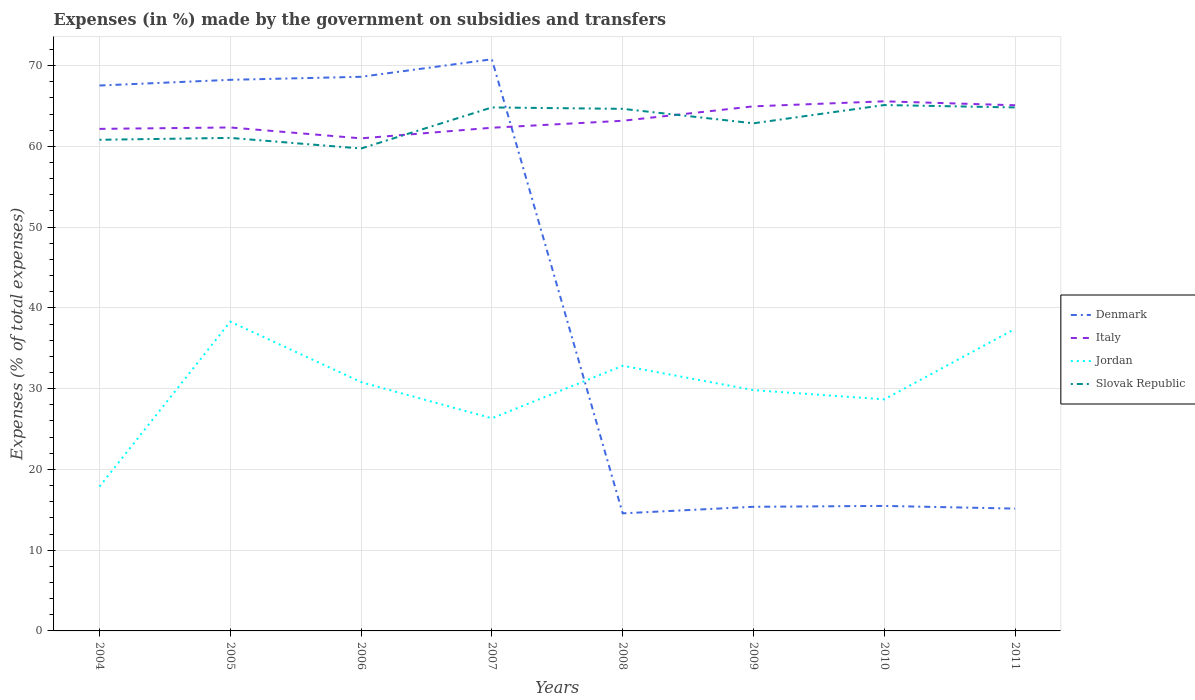Across all years, what is the maximum percentage of expenses made by the government on subsidies and transfers in Slovak Republic?
Your response must be concise. 59.74. What is the total percentage of expenses made by the government on subsidies and transfers in Slovak Republic in the graph?
Your answer should be compact. -3.12. What is the difference between the highest and the second highest percentage of expenses made by the government on subsidies and transfers in Denmark?
Make the answer very short. 56.23. How many lines are there?
Your response must be concise. 4. How many years are there in the graph?
Provide a short and direct response. 8. What is the difference between two consecutive major ticks on the Y-axis?
Your response must be concise. 10. Are the values on the major ticks of Y-axis written in scientific E-notation?
Offer a terse response. No. Does the graph contain any zero values?
Offer a very short reply. No. Does the graph contain grids?
Keep it short and to the point. Yes. How many legend labels are there?
Give a very brief answer. 4. How are the legend labels stacked?
Keep it short and to the point. Vertical. What is the title of the graph?
Ensure brevity in your answer.  Expenses (in %) made by the government on subsidies and transfers. Does "Gambia, The" appear as one of the legend labels in the graph?
Provide a short and direct response. No. What is the label or title of the X-axis?
Provide a succinct answer. Years. What is the label or title of the Y-axis?
Provide a succinct answer. Expenses (% of total expenses). What is the Expenses (% of total expenses) in Denmark in 2004?
Ensure brevity in your answer.  67.54. What is the Expenses (% of total expenses) in Italy in 2004?
Give a very brief answer. 62.17. What is the Expenses (% of total expenses) in Jordan in 2004?
Provide a short and direct response. 17.87. What is the Expenses (% of total expenses) in Slovak Republic in 2004?
Your answer should be very brief. 60.82. What is the Expenses (% of total expenses) in Denmark in 2005?
Offer a very short reply. 68.24. What is the Expenses (% of total expenses) in Italy in 2005?
Provide a short and direct response. 62.34. What is the Expenses (% of total expenses) of Jordan in 2005?
Your answer should be compact. 38.3. What is the Expenses (% of total expenses) of Slovak Republic in 2005?
Your response must be concise. 61.05. What is the Expenses (% of total expenses) in Denmark in 2006?
Offer a very short reply. 68.62. What is the Expenses (% of total expenses) of Italy in 2006?
Your response must be concise. 60.99. What is the Expenses (% of total expenses) in Jordan in 2006?
Your answer should be compact. 30.81. What is the Expenses (% of total expenses) in Slovak Republic in 2006?
Offer a terse response. 59.74. What is the Expenses (% of total expenses) in Denmark in 2007?
Your answer should be very brief. 70.79. What is the Expenses (% of total expenses) in Italy in 2007?
Your answer should be very brief. 62.31. What is the Expenses (% of total expenses) of Jordan in 2007?
Offer a very short reply. 26.33. What is the Expenses (% of total expenses) in Slovak Republic in 2007?
Ensure brevity in your answer.  64.82. What is the Expenses (% of total expenses) of Denmark in 2008?
Ensure brevity in your answer.  14.56. What is the Expenses (% of total expenses) in Italy in 2008?
Provide a succinct answer. 63.17. What is the Expenses (% of total expenses) of Jordan in 2008?
Your answer should be compact. 32.84. What is the Expenses (% of total expenses) of Slovak Republic in 2008?
Offer a very short reply. 64.65. What is the Expenses (% of total expenses) in Denmark in 2009?
Offer a terse response. 15.37. What is the Expenses (% of total expenses) of Italy in 2009?
Make the answer very short. 64.96. What is the Expenses (% of total expenses) of Jordan in 2009?
Provide a short and direct response. 29.82. What is the Expenses (% of total expenses) of Slovak Republic in 2009?
Keep it short and to the point. 62.86. What is the Expenses (% of total expenses) in Denmark in 2010?
Your answer should be very brief. 15.48. What is the Expenses (% of total expenses) in Italy in 2010?
Make the answer very short. 65.58. What is the Expenses (% of total expenses) of Jordan in 2010?
Provide a short and direct response. 28.67. What is the Expenses (% of total expenses) of Slovak Republic in 2010?
Your answer should be very brief. 65.12. What is the Expenses (% of total expenses) of Denmark in 2011?
Provide a short and direct response. 15.15. What is the Expenses (% of total expenses) of Italy in 2011?
Provide a succinct answer. 65.09. What is the Expenses (% of total expenses) in Jordan in 2011?
Give a very brief answer. 37.4. What is the Expenses (% of total expenses) in Slovak Republic in 2011?
Provide a succinct answer. 64.82. Across all years, what is the maximum Expenses (% of total expenses) of Denmark?
Your response must be concise. 70.79. Across all years, what is the maximum Expenses (% of total expenses) in Italy?
Ensure brevity in your answer.  65.58. Across all years, what is the maximum Expenses (% of total expenses) of Jordan?
Ensure brevity in your answer.  38.3. Across all years, what is the maximum Expenses (% of total expenses) in Slovak Republic?
Your answer should be very brief. 65.12. Across all years, what is the minimum Expenses (% of total expenses) in Denmark?
Give a very brief answer. 14.56. Across all years, what is the minimum Expenses (% of total expenses) of Italy?
Your answer should be compact. 60.99. Across all years, what is the minimum Expenses (% of total expenses) of Jordan?
Your answer should be very brief. 17.87. Across all years, what is the minimum Expenses (% of total expenses) of Slovak Republic?
Your answer should be compact. 59.74. What is the total Expenses (% of total expenses) in Denmark in the graph?
Your answer should be compact. 335.73. What is the total Expenses (% of total expenses) of Italy in the graph?
Provide a succinct answer. 506.61. What is the total Expenses (% of total expenses) in Jordan in the graph?
Your answer should be compact. 242.04. What is the total Expenses (% of total expenses) of Slovak Republic in the graph?
Give a very brief answer. 503.87. What is the difference between the Expenses (% of total expenses) in Denmark in 2004 and that in 2005?
Offer a very short reply. -0.7. What is the difference between the Expenses (% of total expenses) of Italy in 2004 and that in 2005?
Provide a succinct answer. -0.17. What is the difference between the Expenses (% of total expenses) of Jordan in 2004 and that in 2005?
Provide a succinct answer. -20.43. What is the difference between the Expenses (% of total expenses) in Slovak Republic in 2004 and that in 2005?
Your answer should be very brief. -0.23. What is the difference between the Expenses (% of total expenses) of Denmark in 2004 and that in 2006?
Your answer should be compact. -1.08. What is the difference between the Expenses (% of total expenses) in Italy in 2004 and that in 2006?
Provide a short and direct response. 1.17. What is the difference between the Expenses (% of total expenses) in Jordan in 2004 and that in 2006?
Your answer should be compact. -12.94. What is the difference between the Expenses (% of total expenses) in Slovak Republic in 2004 and that in 2006?
Keep it short and to the point. 1.08. What is the difference between the Expenses (% of total expenses) in Denmark in 2004 and that in 2007?
Ensure brevity in your answer.  -3.25. What is the difference between the Expenses (% of total expenses) in Italy in 2004 and that in 2007?
Provide a short and direct response. -0.14. What is the difference between the Expenses (% of total expenses) in Jordan in 2004 and that in 2007?
Your answer should be compact. -8.46. What is the difference between the Expenses (% of total expenses) in Slovak Republic in 2004 and that in 2007?
Give a very brief answer. -4. What is the difference between the Expenses (% of total expenses) in Denmark in 2004 and that in 2008?
Give a very brief answer. 52.98. What is the difference between the Expenses (% of total expenses) of Italy in 2004 and that in 2008?
Your response must be concise. -1. What is the difference between the Expenses (% of total expenses) in Jordan in 2004 and that in 2008?
Your answer should be very brief. -14.96. What is the difference between the Expenses (% of total expenses) in Slovak Republic in 2004 and that in 2008?
Keep it short and to the point. -3.83. What is the difference between the Expenses (% of total expenses) of Denmark in 2004 and that in 2009?
Provide a succinct answer. 52.17. What is the difference between the Expenses (% of total expenses) of Italy in 2004 and that in 2009?
Offer a very short reply. -2.79. What is the difference between the Expenses (% of total expenses) of Jordan in 2004 and that in 2009?
Ensure brevity in your answer.  -11.95. What is the difference between the Expenses (% of total expenses) of Slovak Republic in 2004 and that in 2009?
Your answer should be very brief. -2.04. What is the difference between the Expenses (% of total expenses) in Denmark in 2004 and that in 2010?
Give a very brief answer. 52.06. What is the difference between the Expenses (% of total expenses) in Italy in 2004 and that in 2010?
Give a very brief answer. -3.41. What is the difference between the Expenses (% of total expenses) of Jordan in 2004 and that in 2010?
Make the answer very short. -10.8. What is the difference between the Expenses (% of total expenses) of Slovak Republic in 2004 and that in 2010?
Your answer should be very brief. -4.3. What is the difference between the Expenses (% of total expenses) in Denmark in 2004 and that in 2011?
Offer a very short reply. 52.39. What is the difference between the Expenses (% of total expenses) in Italy in 2004 and that in 2011?
Offer a terse response. -2.92. What is the difference between the Expenses (% of total expenses) in Jordan in 2004 and that in 2011?
Ensure brevity in your answer.  -19.53. What is the difference between the Expenses (% of total expenses) in Slovak Republic in 2004 and that in 2011?
Keep it short and to the point. -4. What is the difference between the Expenses (% of total expenses) in Denmark in 2005 and that in 2006?
Give a very brief answer. -0.37. What is the difference between the Expenses (% of total expenses) of Italy in 2005 and that in 2006?
Your answer should be compact. 1.35. What is the difference between the Expenses (% of total expenses) in Jordan in 2005 and that in 2006?
Give a very brief answer. 7.49. What is the difference between the Expenses (% of total expenses) of Slovak Republic in 2005 and that in 2006?
Ensure brevity in your answer.  1.31. What is the difference between the Expenses (% of total expenses) of Denmark in 2005 and that in 2007?
Keep it short and to the point. -2.54. What is the difference between the Expenses (% of total expenses) in Jordan in 2005 and that in 2007?
Your answer should be very brief. 11.97. What is the difference between the Expenses (% of total expenses) in Slovak Republic in 2005 and that in 2007?
Keep it short and to the point. -3.77. What is the difference between the Expenses (% of total expenses) in Denmark in 2005 and that in 2008?
Ensure brevity in your answer.  53.68. What is the difference between the Expenses (% of total expenses) of Italy in 2005 and that in 2008?
Your answer should be compact. -0.83. What is the difference between the Expenses (% of total expenses) of Jordan in 2005 and that in 2008?
Your answer should be compact. 5.47. What is the difference between the Expenses (% of total expenses) in Slovak Republic in 2005 and that in 2008?
Offer a terse response. -3.6. What is the difference between the Expenses (% of total expenses) in Denmark in 2005 and that in 2009?
Keep it short and to the point. 52.87. What is the difference between the Expenses (% of total expenses) in Italy in 2005 and that in 2009?
Give a very brief answer. -2.62. What is the difference between the Expenses (% of total expenses) in Jordan in 2005 and that in 2009?
Make the answer very short. 8.48. What is the difference between the Expenses (% of total expenses) in Slovak Republic in 2005 and that in 2009?
Offer a terse response. -1.81. What is the difference between the Expenses (% of total expenses) of Denmark in 2005 and that in 2010?
Your response must be concise. 52.76. What is the difference between the Expenses (% of total expenses) of Italy in 2005 and that in 2010?
Offer a terse response. -3.24. What is the difference between the Expenses (% of total expenses) of Jordan in 2005 and that in 2010?
Keep it short and to the point. 9.63. What is the difference between the Expenses (% of total expenses) of Slovak Republic in 2005 and that in 2010?
Keep it short and to the point. -4.07. What is the difference between the Expenses (% of total expenses) in Denmark in 2005 and that in 2011?
Your answer should be compact. 53.09. What is the difference between the Expenses (% of total expenses) in Italy in 2005 and that in 2011?
Provide a short and direct response. -2.75. What is the difference between the Expenses (% of total expenses) of Jordan in 2005 and that in 2011?
Ensure brevity in your answer.  0.9. What is the difference between the Expenses (% of total expenses) of Slovak Republic in 2005 and that in 2011?
Make the answer very short. -3.77. What is the difference between the Expenses (% of total expenses) in Denmark in 2006 and that in 2007?
Keep it short and to the point. -2.17. What is the difference between the Expenses (% of total expenses) of Italy in 2006 and that in 2007?
Keep it short and to the point. -1.32. What is the difference between the Expenses (% of total expenses) of Jordan in 2006 and that in 2007?
Offer a terse response. 4.48. What is the difference between the Expenses (% of total expenses) of Slovak Republic in 2006 and that in 2007?
Provide a succinct answer. -5.09. What is the difference between the Expenses (% of total expenses) of Denmark in 2006 and that in 2008?
Keep it short and to the point. 54.06. What is the difference between the Expenses (% of total expenses) in Italy in 2006 and that in 2008?
Your answer should be compact. -2.18. What is the difference between the Expenses (% of total expenses) of Jordan in 2006 and that in 2008?
Keep it short and to the point. -2.03. What is the difference between the Expenses (% of total expenses) in Slovak Republic in 2006 and that in 2008?
Ensure brevity in your answer.  -4.91. What is the difference between the Expenses (% of total expenses) of Denmark in 2006 and that in 2009?
Your response must be concise. 53.24. What is the difference between the Expenses (% of total expenses) in Italy in 2006 and that in 2009?
Ensure brevity in your answer.  -3.96. What is the difference between the Expenses (% of total expenses) in Slovak Republic in 2006 and that in 2009?
Your response must be concise. -3.12. What is the difference between the Expenses (% of total expenses) of Denmark in 2006 and that in 2010?
Keep it short and to the point. 53.14. What is the difference between the Expenses (% of total expenses) in Italy in 2006 and that in 2010?
Your response must be concise. -4.59. What is the difference between the Expenses (% of total expenses) of Jordan in 2006 and that in 2010?
Offer a very short reply. 2.14. What is the difference between the Expenses (% of total expenses) in Slovak Republic in 2006 and that in 2010?
Offer a terse response. -5.38. What is the difference between the Expenses (% of total expenses) in Denmark in 2006 and that in 2011?
Offer a terse response. 53.47. What is the difference between the Expenses (% of total expenses) in Italy in 2006 and that in 2011?
Keep it short and to the point. -4.1. What is the difference between the Expenses (% of total expenses) of Jordan in 2006 and that in 2011?
Keep it short and to the point. -6.59. What is the difference between the Expenses (% of total expenses) of Slovak Republic in 2006 and that in 2011?
Offer a terse response. -5.08. What is the difference between the Expenses (% of total expenses) of Denmark in 2007 and that in 2008?
Provide a succinct answer. 56.23. What is the difference between the Expenses (% of total expenses) in Italy in 2007 and that in 2008?
Provide a short and direct response. -0.86. What is the difference between the Expenses (% of total expenses) of Jordan in 2007 and that in 2008?
Your answer should be very brief. -6.51. What is the difference between the Expenses (% of total expenses) of Slovak Republic in 2007 and that in 2008?
Ensure brevity in your answer.  0.17. What is the difference between the Expenses (% of total expenses) of Denmark in 2007 and that in 2009?
Your response must be concise. 55.41. What is the difference between the Expenses (% of total expenses) in Italy in 2007 and that in 2009?
Your answer should be compact. -2.65. What is the difference between the Expenses (% of total expenses) in Jordan in 2007 and that in 2009?
Make the answer very short. -3.49. What is the difference between the Expenses (% of total expenses) of Slovak Republic in 2007 and that in 2009?
Ensure brevity in your answer.  1.96. What is the difference between the Expenses (% of total expenses) of Denmark in 2007 and that in 2010?
Your response must be concise. 55.31. What is the difference between the Expenses (% of total expenses) in Italy in 2007 and that in 2010?
Your answer should be compact. -3.27. What is the difference between the Expenses (% of total expenses) of Jordan in 2007 and that in 2010?
Give a very brief answer. -2.34. What is the difference between the Expenses (% of total expenses) of Slovak Republic in 2007 and that in 2010?
Provide a short and direct response. -0.3. What is the difference between the Expenses (% of total expenses) of Denmark in 2007 and that in 2011?
Make the answer very short. 55.64. What is the difference between the Expenses (% of total expenses) of Italy in 2007 and that in 2011?
Offer a very short reply. -2.78. What is the difference between the Expenses (% of total expenses) in Jordan in 2007 and that in 2011?
Your response must be concise. -11.07. What is the difference between the Expenses (% of total expenses) in Slovak Republic in 2007 and that in 2011?
Provide a short and direct response. 0. What is the difference between the Expenses (% of total expenses) of Denmark in 2008 and that in 2009?
Your response must be concise. -0.81. What is the difference between the Expenses (% of total expenses) in Italy in 2008 and that in 2009?
Keep it short and to the point. -1.79. What is the difference between the Expenses (% of total expenses) in Jordan in 2008 and that in 2009?
Your response must be concise. 3.02. What is the difference between the Expenses (% of total expenses) of Slovak Republic in 2008 and that in 2009?
Your answer should be very brief. 1.79. What is the difference between the Expenses (% of total expenses) in Denmark in 2008 and that in 2010?
Provide a short and direct response. -0.92. What is the difference between the Expenses (% of total expenses) in Italy in 2008 and that in 2010?
Your response must be concise. -2.41. What is the difference between the Expenses (% of total expenses) of Jordan in 2008 and that in 2010?
Provide a short and direct response. 4.16. What is the difference between the Expenses (% of total expenses) in Slovak Republic in 2008 and that in 2010?
Keep it short and to the point. -0.47. What is the difference between the Expenses (% of total expenses) in Denmark in 2008 and that in 2011?
Provide a succinct answer. -0.59. What is the difference between the Expenses (% of total expenses) in Italy in 2008 and that in 2011?
Make the answer very short. -1.92. What is the difference between the Expenses (% of total expenses) in Jordan in 2008 and that in 2011?
Your answer should be compact. -4.57. What is the difference between the Expenses (% of total expenses) in Slovak Republic in 2008 and that in 2011?
Provide a short and direct response. -0.17. What is the difference between the Expenses (% of total expenses) of Denmark in 2009 and that in 2010?
Offer a terse response. -0.11. What is the difference between the Expenses (% of total expenses) of Italy in 2009 and that in 2010?
Make the answer very short. -0.62. What is the difference between the Expenses (% of total expenses) in Jordan in 2009 and that in 2010?
Give a very brief answer. 1.14. What is the difference between the Expenses (% of total expenses) of Slovak Republic in 2009 and that in 2010?
Ensure brevity in your answer.  -2.26. What is the difference between the Expenses (% of total expenses) of Denmark in 2009 and that in 2011?
Offer a very short reply. 0.22. What is the difference between the Expenses (% of total expenses) in Italy in 2009 and that in 2011?
Provide a succinct answer. -0.13. What is the difference between the Expenses (% of total expenses) of Jordan in 2009 and that in 2011?
Make the answer very short. -7.58. What is the difference between the Expenses (% of total expenses) in Slovak Republic in 2009 and that in 2011?
Offer a terse response. -1.96. What is the difference between the Expenses (% of total expenses) of Denmark in 2010 and that in 2011?
Make the answer very short. 0.33. What is the difference between the Expenses (% of total expenses) of Italy in 2010 and that in 2011?
Provide a succinct answer. 0.49. What is the difference between the Expenses (% of total expenses) in Jordan in 2010 and that in 2011?
Your answer should be very brief. -8.73. What is the difference between the Expenses (% of total expenses) of Slovak Republic in 2010 and that in 2011?
Keep it short and to the point. 0.3. What is the difference between the Expenses (% of total expenses) in Denmark in 2004 and the Expenses (% of total expenses) in Italy in 2005?
Give a very brief answer. 5.19. What is the difference between the Expenses (% of total expenses) of Denmark in 2004 and the Expenses (% of total expenses) of Jordan in 2005?
Your answer should be compact. 29.23. What is the difference between the Expenses (% of total expenses) of Denmark in 2004 and the Expenses (% of total expenses) of Slovak Republic in 2005?
Provide a succinct answer. 6.49. What is the difference between the Expenses (% of total expenses) of Italy in 2004 and the Expenses (% of total expenses) of Jordan in 2005?
Your answer should be compact. 23.86. What is the difference between the Expenses (% of total expenses) in Italy in 2004 and the Expenses (% of total expenses) in Slovak Republic in 2005?
Your answer should be compact. 1.12. What is the difference between the Expenses (% of total expenses) of Jordan in 2004 and the Expenses (% of total expenses) of Slovak Republic in 2005?
Make the answer very short. -43.18. What is the difference between the Expenses (% of total expenses) of Denmark in 2004 and the Expenses (% of total expenses) of Italy in 2006?
Keep it short and to the point. 6.54. What is the difference between the Expenses (% of total expenses) in Denmark in 2004 and the Expenses (% of total expenses) in Jordan in 2006?
Your response must be concise. 36.73. What is the difference between the Expenses (% of total expenses) of Italy in 2004 and the Expenses (% of total expenses) of Jordan in 2006?
Keep it short and to the point. 31.36. What is the difference between the Expenses (% of total expenses) in Italy in 2004 and the Expenses (% of total expenses) in Slovak Republic in 2006?
Keep it short and to the point. 2.43. What is the difference between the Expenses (% of total expenses) of Jordan in 2004 and the Expenses (% of total expenses) of Slovak Republic in 2006?
Your response must be concise. -41.87. What is the difference between the Expenses (% of total expenses) in Denmark in 2004 and the Expenses (% of total expenses) in Italy in 2007?
Ensure brevity in your answer.  5.23. What is the difference between the Expenses (% of total expenses) of Denmark in 2004 and the Expenses (% of total expenses) of Jordan in 2007?
Provide a short and direct response. 41.21. What is the difference between the Expenses (% of total expenses) of Denmark in 2004 and the Expenses (% of total expenses) of Slovak Republic in 2007?
Make the answer very short. 2.71. What is the difference between the Expenses (% of total expenses) in Italy in 2004 and the Expenses (% of total expenses) in Jordan in 2007?
Give a very brief answer. 35.84. What is the difference between the Expenses (% of total expenses) in Italy in 2004 and the Expenses (% of total expenses) in Slovak Republic in 2007?
Make the answer very short. -2.65. What is the difference between the Expenses (% of total expenses) in Jordan in 2004 and the Expenses (% of total expenses) in Slovak Republic in 2007?
Keep it short and to the point. -46.95. What is the difference between the Expenses (% of total expenses) in Denmark in 2004 and the Expenses (% of total expenses) in Italy in 2008?
Provide a short and direct response. 4.37. What is the difference between the Expenses (% of total expenses) in Denmark in 2004 and the Expenses (% of total expenses) in Jordan in 2008?
Offer a very short reply. 34.7. What is the difference between the Expenses (% of total expenses) of Denmark in 2004 and the Expenses (% of total expenses) of Slovak Republic in 2008?
Keep it short and to the point. 2.89. What is the difference between the Expenses (% of total expenses) in Italy in 2004 and the Expenses (% of total expenses) in Jordan in 2008?
Offer a terse response. 29.33. What is the difference between the Expenses (% of total expenses) in Italy in 2004 and the Expenses (% of total expenses) in Slovak Republic in 2008?
Your response must be concise. -2.48. What is the difference between the Expenses (% of total expenses) of Jordan in 2004 and the Expenses (% of total expenses) of Slovak Republic in 2008?
Offer a terse response. -46.78. What is the difference between the Expenses (% of total expenses) in Denmark in 2004 and the Expenses (% of total expenses) in Italy in 2009?
Your answer should be very brief. 2.58. What is the difference between the Expenses (% of total expenses) of Denmark in 2004 and the Expenses (% of total expenses) of Jordan in 2009?
Give a very brief answer. 37.72. What is the difference between the Expenses (% of total expenses) in Denmark in 2004 and the Expenses (% of total expenses) in Slovak Republic in 2009?
Your response must be concise. 4.68. What is the difference between the Expenses (% of total expenses) in Italy in 2004 and the Expenses (% of total expenses) in Jordan in 2009?
Provide a short and direct response. 32.35. What is the difference between the Expenses (% of total expenses) in Italy in 2004 and the Expenses (% of total expenses) in Slovak Republic in 2009?
Your response must be concise. -0.69. What is the difference between the Expenses (% of total expenses) of Jordan in 2004 and the Expenses (% of total expenses) of Slovak Republic in 2009?
Offer a very short reply. -44.99. What is the difference between the Expenses (% of total expenses) in Denmark in 2004 and the Expenses (% of total expenses) in Italy in 2010?
Make the answer very short. 1.96. What is the difference between the Expenses (% of total expenses) in Denmark in 2004 and the Expenses (% of total expenses) in Jordan in 2010?
Provide a succinct answer. 38.86. What is the difference between the Expenses (% of total expenses) of Denmark in 2004 and the Expenses (% of total expenses) of Slovak Republic in 2010?
Provide a short and direct response. 2.42. What is the difference between the Expenses (% of total expenses) in Italy in 2004 and the Expenses (% of total expenses) in Jordan in 2010?
Your answer should be very brief. 33.49. What is the difference between the Expenses (% of total expenses) of Italy in 2004 and the Expenses (% of total expenses) of Slovak Republic in 2010?
Keep it short and to the point. -2.95. What is the difference between the Expenses (% of total expenses) of Jordan in 2004 and the Expenses (% of total expenses) of Slovak Republic in 2010?
Provide a succinct answer. -47.25. What is the difference between the Expenses (% of total expenses) in Denmark in 2004 and the Expenses (% of total expenses) in Italy in 2011?
Your answer should be very brief. 2.45. What is the difference between the Expenses (% of total expenses) in Denmark in 2004 and the Expenses (% of total expenses) in Jordan in 2011?
Provide a short and direct response. 30.13. What is the difference between the Expenses (% of total expenses) in Denmark in 2004 and the Expenses (% of total expenses) in Slovak Republic in 2011?
Your answer should be compact. 2.72. What is the difference between the Expenses (% of total expenses) of Italy in 2004 and the Expenses (% of total expenses) of Jordan in 2011?
Your response must be concise. 24.77. What is the difference between the Expenses (% of total expenses) of Italy in 2004 and the Expenses (% of total expenses) of Slovak Republic in 2011?
Offer a terse response. -2.65. What is the difference between the Expenses (% of total expenses) of Jordan in 2004 and the Expenses (% of total expenses) of Slovak Republic in 2011?
Give a very brief answer. -46.95. What is the difference between the Expenses (% of total expenses) in Denmark in 2005 and the Expenses (% of total expenses) in Italy in 2006?
Ensure brevity in your answer.  7.25. What is the difference between the Expenses (% of total expenses) in Denmark in 2005 and the Expenses (% of total expenses) in Jordan in 2006?
Your answer should be very brief. 37.43. What is the difference between the Expenses (% of total expenses) of Denmark in 2005 and the Expenses (% of total expenses) of Slovak Republic in 2006?
Keep it short and to the point. 8.5. What is the difference between the Expenses (% of total expenses) of Italy in 2005 and the Expenses (% of total expenses) of Jordan in 2006?
Your answer should be compact. 31.53. What is the difference between the Expenses (% of total expenses) of Italy in 2005 and the Expenses (% of total expenses) of Slovak Republic in 2006?
Ensure brevity in your answer.  2.61. What is the difference between the Expenses (% of total expenses) of Jordan in 2005 and the Expenses (% of total expenses) of Slovak Republic in 2006?
Keep it short and to the point. -21.43. What is the difference between the Expenses (% of total expenses) of Denmark in 2005 and the Expenses (% of total expenses) of Italy in 2007?
Provide a short and direct response. 5.93. What is the difference between the Expenses (% of total expenses) of Denmark in 2005 and the Expenses (% of total expenses) of Jordan in 2007?
Your answer should be compact. 41.91. What is the difference between the Expenses (% of total expenses) of Denmark in 2005 and the Expenses (% of total expenses) of Slovak Republic in 2007?
Your answer should be compact. 3.42. What is the difference between the Expenses (% of total expenses) in Italy in 2005 and the Expenses (% of total expenses) in Jordan in 2007?
Your response must be concise. 36.01. What is the difference between the Expenses (% of total expenses) of Italy in 2005 and the Expenses (% of total expenses) of Slovak Republic in 2007?
Ensure brevity in your answer.  -2.48. What is the difference between the Expenses (% of total expenses) of Jordan in 2005 and the Expenses (% of total expenses) of Slovak Republic in 2007?
Offer a very short reply. -26.52. What is the difference between the Expenses (% of total expenses) in Denmark in 2005 and the Expenses (% of total expenses) in Italy in 2008?
Keep it short and to the point. 5.07. What is the difference between the Expenses (% of total expenses) in Denmark in 2005 and the Expenses (% of total expenses) in Jordan in 2008?
Your answer should be compact. 35.41. What is the difference between the Expenses (% of total expenses) in Denmark in 2005 and the Expenses (% of total expenses) in Slovak Republic in 2008?
Your response must be concise. 3.59. What is the difference between the Expenses (% of total expenses) of Italy in 2005 and the Expenses (% of total expenses) of Jordan in 2008?
Your answer should be compact. 29.51. What is the difference between the Expenses (% of total expenses) of Italy in 2005 and the Expenses (% of total expenses) of Slovak Republic in 2008?
Give a very brief answer. -2.31. What is the difference between the Expenses (% of total expenses) in Jordan in 2005 and the Expenses (% of total expenses) in Slovak Republic in 2008?
Give a very brief answer. -26.35. What is the difference between the Expenses (% of total expenses) of Denmark in 2005 and the Expenses (% of total expenses) of Italy in 2009?
Keep it short and to the point. 3.28. What is the difference between the Expenses (% of total expenses) in Denmark in 2005 and the Expenses (% of total expenses) in Jordan in 2009?
Provide a short and direct response. 38.42. What is the difference between the Expenses (% of total expenses) of Denmark in 2005 and the Expenses (% of total expenses) of Slovak Republic in 2009?
Offer a very short reply. 5.38. What is the difference between the Expenses (% of total expenses) in Italy in 2005 and the Expenses (% of total expenses) in Jordan in 2009?
Offer a terse response. 32.52. What is the difference between the Expenses (% of total expenses) in Italy in 2005 and the Expenses (% of total expenses) in Slovak Republic in 2009?
Offer a terse response. -0.52. What is the difference between the Expenses (% of total expenses) of Jordan in 2005 and the Expenses (% of total expenses) of Slovak Republic in 2009?
Make the answer very short. -24.56. What is the difference between the Expenses (% of total expenses) of Denmark in 2005 and the Expenses (% of total expenses) of Italy in 2010?
Your response must be concise. 2.66. What is the difference between the Expenses (% of total expenses) of Denmark in 2005 and the Expenses (% of total expenses) of Jordan in 2010?
Give a very brief answer. 39.57. What is the difference between the Expenses (% of total expenses) in Denmark in 2005 and the Expenses (% of total expenses) in Slovak Republic in 2010?
Ensure brevity in your answer.  3.12. What is the difference between the Expenses (% of total expenses) in Italy in 2005 and the Expenses (% of total expenses) in Jordan in 2010?
Offer a terse response. 33.67. What is the difference between the Expenses (% of total expenses) in Italy in 2005 and the Expenses (% of total expenses) in Slovak Republic in 2010?
Offer a terse response. -2.78. What is the difference between the Expenses (% of total expenses) of Jordan in 2005 and the Expenses (% of total expenses) of Slovak Republic in 2010?
Your response must be concise. -26.82. What is the difference between the Expenses (% of total expenses) in Denmark in 2005 and the Expenses (% of total expenses) in Italy in 2011?
Make the answer very short. 3.15. What is the difference between the Expenses (% of total expenses) of Denmark in 2005 and the Expenses (% of total expenses) of Jordan in 2011?
Ensure brevity in your answer.  30.84. What is the difference between the Expenses (% of total expenses) in Denmark in 2005 and the Expenses (% of total expenses) in Slovak Republic in 2011?
Provide a succinct answer. 3.42. What is the difference between the Expenses (% of total expenses) of Italy in 2005 and the Expenses (% of total expenses) of Jordan in 2011?
Offer a terse response. 24.94. What is the difference between the Expenses (% of total expenses) in Italy in 2005 and the Expenses (% of total expenses) in Slovak Republic in 2011?
Your answer should be very brief. -2.48. What is the difference between the Expenses (% of total expenses) of Jordan in 2005 and the Expenses (% of total expenses) of Slovak Republic in 2011?
Offer a very short reply. -26.52. What is the difference between the Expenses (% of total expenses) in Denmark in 2006 and the Expenses (% of total expenses) in Italy in 2007?
Give a very brief answer. 6.31. What is the difference between the Expenses (% of total expenses) of Denmark in 2006 and the Expenses (% of total expenses) of Jordan in 2007?
Your response must be concise. 42.29. What is the difference between the Expenses (% of total expenses) in Denmark in 2006 and the Expenses (% of total expenses) in Slovak Republic in 2007?
Provide a succinct answer. 3.79. What is the difference between the Expenses (% of total expenses) of Italy in 2006 and the Expenses (% of total expenses) of Jordan in 2007?
Provide a short and direct response. 34.66. What is the difference between the Expenses (% of total expenses) of Italy in 2006 and the Expenses (% of total expenses) of Slovak Republic in 2007?
Ensure brevity in your answer.  -3.83. What is the difference between the Expenses (% of total expenses) of Jordan in 2006 and the Expenses (% of total expenses) of Slovak Republic in 2007?
Offer a very short reply. -34.01. What is the difference between the Expenses (% of total expenses) in Denmark in 2006 and the Expenses (% of total expenses) in Italy in 2008?
Offer a very short reply. 5.45. What is the difference between the Expenses (% of total expenses) in Denmark in 2006 and the Expenses (% of total expenses) in Jordan in 2008?
Your answer should be very brief. 35.78. What is the difference between the Expenses (% of total expenses) in Denmark in 2006 and the Expenses (% of total expenses) in Slovak Republic in 2008?
Give a very brief answer. 3.97. What is the difference between the Expenses (% of total expenses) of Italy in 2006 and the Expenses (% of total expenses) of Jordan in 2008?
Your answer should be very brief. 28.16. What is the difference between the Expenses (% of total expenses) in Italy in 2006 and the Expenses (% of total expenses) in Slovak Republic in 2008?
Provide a succinct answer. -3.65. What is the difference between the Expenses (% of total expenses) of Jordan in 2006 and the Expenses (% of total expenses) of Slovak Republic in 2008?
Your answer should be compact. -33.84. What is the difference between the Expenses (% of total expenses) in Denmark in 2006 and the Expenses (% of total expenses) in Italy in 2009?
Your response must be concise. 3.66. What is the difference between the Expenses (% of total expenses) in Denmark in 2006 and the Expenses (% of total expenses) in Jordan in 2009?
Your response must be concise. 38.8. What is the difference between the Expenses (% of total expenses) of Denmark in 2006 and the Expenses (% of total expenses) of Slovak Republic in 2009?
Keep it short and to the point. 5.76. What is the difference between the Expenses (% of total expenses) in Italy in 2006 and the Expenses (% of total expenses) in Jordan in 2009?
Offer a terse response. 31.18. What is the difference between the Expenses (% of total expenses) in Italy in 2006 and the Expenses (% of total expenses) in Slovak Republic in 2009?
Ensure brevity in your answer.  -1.86. What is the difference between the Expenses (% of total expenses) of Jordan in 2006 and the Expenses (% of total expenses) of Slovak Republic in 2009?
Your answer should be very brief. -32.05. What is the difference between the Expenses (% of total expenses) of Denmark in 2006 and the Expenses (% of total expenses) of Italy in 2010?
Your response must be concise. 3.03. What is the difference between the Expenses (% of total expenses) in Denmark in 2006 and the Expenses (% of total expenses) in Jordan in 2010?
Keep it short and to the point. 39.94. What is the difference between the Expenses (% of total expenses) in Denmark in 2006 and the Expenses (% of total expenses) in Slovak Republic in 2010?
Your answer should be very brief. 3.5. What is the difference between the Expenses (% of total expenses) of Italy in 2006 and the Expenses (% of total expenses) of Jordan in 2010?
Offer a terse response. 32.32. What is the difference between the Expenses (% of total expenses) in Italy in 2006 and the Expenses (% of total expenses) in Slovak Republic in 2010?
Ensure brevity in your answer.  -4.13. What is the difference between the Expenses (% of total expenses) in Jordan in 2006 and the Expenses (% of total expenses) in Slovak Republic in 2010?
Make the answer very short. -34.31. What is the difference between the Expenses (% of total expenses) in Denmark in 2006 and the Expenses (% of total expenses) in Italy in 2011?
Offer a terse response. 3.53. What is the difference between the Expenses (% of total expenses) of Denmark in 2006 and the Expenses (% of total expenses) of Jordan in 2011?
Offer a terse response. 31.21. What is the difference between the Expenses (% of total expenses) in Denmark in 2006 and the Expenses (% of total expenses) in Slovak Republic in 2011?
Make the answer very short. 3.8. What is the difference between the Expenses (% of total expenses) of Italy in 2006 and the Expenses (% of total expenses) of Jordan in 2011?
Offer a very short reply. 23.59. What is the difference between the Expenses (% of total expenses) of Italy in 2006 and the Expenses (% of total expenses) of Slovak Republic in 2011?
Offer a terse response. -3.83. What is the difference between the Expenses (% of total expenses) in Jordan in 2006 and the Expenses (% of total expenses) in Slovak Republic in 2011?
Offer a very short reply. -34.01. What is the difference between the Expenses (% of total expenses) of Denmark in 2007 and the Expenses (% of total expenses) of Italy in 2008?
Your answer should be compact. 7.62. What is the difference between the Expenses (% of total expenses) of Denmark in 2007 and the Expenses (% of total expenses) of Jordan in 2008?
Your answer should be compact. 37.95. What is the difference between the Expenses (% of total expenses) of Denmark in 2007 and the Expenses (% of total expenses) of Slovak Republic in 2008?
Make the answer very short. 6.14. What is the difference between the Expenses (% of total expenses) of Italy in 2007 and the Expenses (% of total expenses) of Jordan in 2008?
Give a very brief answer. 29.47. What is the difference between the Expenses (% of total expenses) of Italy in 2007 and the Expenses (% of total expenses) of Slovak Republic in 2008?
Provide a short and direct response. -2.34. What is the difference between the Expenses (% of total expenses) in Jordan in 2007 and the Expenses (% of total expenses) in Slovak Republic in 2008?
Your answer should be compact. -38.32. What is the difference between the Expenses (% of total expenses) of Denmark in 2007 and the Expenses (% of total expenses) of Italy in 2009?
Provide a succinct answer. 5.83. What is the difference between the Expenses (% of total expenses) of Denmark in 2007 and the Expenses (% of total expenses) of Jordan in 2009?
Provide a short and direct response. 40.97. What is the difference between the Expenses (% of total expenses) of Denmark in 2007 and the Expenses (% of total expenses) of Slovak Republic in 2009?
Provide a succinct answer. 7.93. What is the difference between the Expenses (% of total expenses) of Italy in 2007 and the Expenses (% of total expenses) of Jordan in 2009?
Offer a terse response. 32.49. What is the difference between the Expenses (% of total expenses) of Italy in 2007 and the Expenses (% of total expenses) of Slovak Republic in 2009?
Provide a short and direct response. -0.55. What is the difference between the Expenses (% of total expenses) of Jordan in 2007 and the Expenses (% of total expenses) of Slovak Republic in 2009?
Your response must be concise. -36.53. What is the difference between the Expenses (% of total expenses) of Denmark in 2007 and the Expenses (% of total expenses) of Italy in 2010?
Your answer should be very brief. 5.2. What is the difference between the Expenses (% of total expenses) of Denmark in 2007 and the Expenses (% of total expenses) of Jordan in 2010?
Your answer should be very brief. 42.11. What is the difference between the Expenses (% of total expenses) in Denmark in 2007 and the Expenses (% of total expenses) in Slovak Republic in 2010?
Provide a succinct answer. 5.67. What is the difference between the Expenses (% of total expenses) in Italy in 2007 and the Expenses (% of total expenses) in Jordan in 2010?
Keep it short and to the point. 33.64. What is the difference between the Expenses (% of total expenses) in Italy in 2007 and the Expenses (% of total expenses) in Slovak Republic in 2010?
Ensure brevity in your answer.  -2.81. What is the difference between the Expenses (% of total expenses) of Jordan in 2007 and the Expenses (% of total expenses) of Slovak Republic in 2010?
Give a very brief answer. -38.79. What is the difference between the Expenses (% of total expenses) of Denmark in 2007 and the Expenses (% of total expenses) of Italy in 2011?
Your answer should be very brief. 5.7. What is the difference between the Expenses (% of total expenses) in Denmark in 2007 and the Expenses (% of total expenses) in Jordan in 2011?
Provide a short and direct response. 33.38. What is the difference between the Expenses (% of total expenses) in Denmark in 2007 and the Expenses (% of total expenses) in Slovak Republic in 2011?
Your answer should be very brief. 5.97. What is the difference between the Expenses (% of total expenses) of Italy in 2007 and the Expenses (% of total expenses) of Jordan in 2011?
Ensure brevity in your answer.  24.91. What is the difference between the Expenses (% of total expenses) of Italy in 2007 and the Expenses (% of total expenses) of Slovak Republic in 2011?
Ensure brevity in your answer.  -2.51. What is the difference between the Expenses (% of total expenses) in Jordan in 2007 and the Expenses (% of total expenses) in Slovak Republic in 2011?
Your answer should be compact. -38.49. What is the difference between the Expenses (% of total expenses) of Denmark in 2008 and the Expenses (% of total expenses) of Italy in 2009?
Make the answer very short. -50.4. What is the difference between the Expenses (% of total expenses) in Denmark in 2008 and the Expenses (% of total expenses) in Jordan in 2009?
Your answer should be very brief. -15.26. What is the difference between the Expenses (% of total expenses) in Denmark in 2008 and the Expenses (% of total expenses) in Slovak Republic in 2009?
Your response must be concise. -48.3. What is the difference between the Expenses (% of total expenses) of Italy in 2008 and the Expenses (% of total expenses) of Jordan in 2009?
Provide a short and direct response. 33.35. What is the difference between the Expenses (% of total expenses) of Italy in 2008 and the Expenses (% of total expenses) of Slovak Republic in 2009?
Keep it short and to the point. 0.31. What is the difference between the Expenses (% of total expenses) in Jordan in 2008 and the Expenses (% of total expenses) in Slovak Republic in 2009?
Your response must be concise. -30.02. What is the difference between the Expenses (% of total expenses) of Denmark in 2008 and the Expenses (% of total expenses) of Italy in 2010?
Your response must be concise. -51.02. What is the difference between the Expenses (% of total expenses) of Denmark in 2008 and the Expenses (% of total expenses) of Jordan in 2010?
Provide a short and direct response. -14.11. What is the difference between the Expenses (% of total expenses) in Denmark in 2008 and the Expenses (% of total expenses) in Slovak Republic in 2010?
Give a very brief answer. -50.56. What is the difference between the Expenses (% of total expenses) in Italy in 2008 and the Expenses (% of total expenses) in Jordan in 2010?
Give a very brief answer. 34.5. What is the difference between the Expenses (% of total expenses) in Italy in 2008 and the Expenses (% of total expenses) in Slovak Republic in 2010?
Offer a very short reply. -1.95. What is the difference between the Expenses (% of total expenses) of Jordan in 2008 and the Expenses (% of total expenses) of Slovak Republic in 2010?
Provide a short and direct response. -32.28. What is the difference between the Expenses (% of total expenses) of Denmark in 2008 and the Expenses (% of total expenses) of Italy in 2011?
Offer a very short reply. -50.53. What is the difference between the Expenses (% of total expenses) in Denmark in 2008 and the Expenses (% of total expenses) in Jordan in 2011?
Your response must be concise. -22.84. What is the difference between the Expenses (% of total expenses) in Denmark in 2008 and the Expenses (% of total expenses) in Slovak Republic in 2011?
Offer a terse response. -50.26. What is the difference between the Expenses (% of total expenses) in Italy in 2008 and the Expenses (% of total expenses) in Jordan in 2011?
Your answer should be very brief. 25.77. What is the difference between the Expenses (% of total expenses) in Italy in 2008 and the Expenses (% of total expenses) in Slovak Republic in 2011?
Provide a short and direct response. -1.65. What is the difference between the Expenses (% of total expenses) of Jordan in 2008 and the Expenses (% of total expenses) of Slovak Republic in 2011?
Keep it short and to the point. -31.98. What is the difference between the Expenses (% of total expenses) in Denmark in 2009 and the Expenses (% of total expenses) in Italy in 2010?
Your response must be concise. -50.21. What is the difference between the Expenses (% of total expenses) in Denmark in 2009 and the Expenses (% of total expenses) in Jordan in 2010?
Provide a short and direct response. -13.3. What is the difference between the Expenses (% of total expenses) in Denmark in 2009 and the Expenses (% of total expenses) in Slovak Republic in 2010?
Provide a short and direct response. -49.75. What is the difference between the Expenses (% of total expenses) of Italy in 2009 and the Expenses (% of total expenses) of Jordan in 2010?
Give a very brief answer. 36.28. What is the difference between the Expenses (% of total expenses) in Italy in 2009 and the Expenses (% of total expenses) in Slovak Republic in 2010?
Provide a short and direct response. -0.16. What is the difference between the Expenses (% of total expenses) of Jordan in 2009 and the Expenses (% of total expenses) of Slovak Republic in 2010?
Ensure brevity in your answer.  -35.3. What is the difference between the Expenses (% of total expenses) in Denmark in 2009 and the Expenses (% of total expenses) in Italy in 2011?
Your answer should be compact. -49.72. What is the difference between the Expenses (% of total expenses) of Denmark in 2009 and the Expenses (% of total expenses) of Jordan in 2011?
Keep it short and to the point. -22.03. What is the difference between the Expenses (% of total expenses) in Denmark in 2009 and the Expenses (% of total expenses) in Slovak Republic in 2011?
Provide a short and direct response. -49.45. What is the difference between the Expenses (% of total expenses) in Italy in 2009 and the Expenses (% of total expenses) in Jordan in 2011?
Offer a terse response. 27.56. What is the difference between the Expenses (% of total expenses) in Italy in 2009 and the Expenses (% of total expenses) in Slovak Republic in 2011?
Provide a succinct answer. 0.14. What is the difference between the Expenses (% of total expenses) of Jordan in 2009 and the Expenses (% of total expenses) of Slovak Republic in 2011?
Your answer should be very brief. -35. What is the difference between the Expenses (% of total expenses) in Denmark in 2010 and the Expenses (% of total expenses) in Italy in 2011?
Give a very brief answer. -49.61. What is the difference between the Expenses (% of total expenses) of Denmark in 2010 and the Expenses (% of total expenses) of Jordan in 2011?
Your answer should be compact. -21.92. What is the difference between the Expenses (% of total expenses) in Denmark in 2010 and the Expenses (% of total expenses) in Slovak Republic in 2011?
Make the answer very short. -49.34. What is the difference between the Expenses (% of total expenses) in Italy in 2010 and the Expenses (% of total expenses) in Jordan in 2011?
Make the answer very short. 28.18. What is the difference between the Expenses (% of total expenses) of Italy in 2010 and the Expenses (% of total expenses) of Slovak Republic in 2011?
Provide a succinct answer. 0.76. What is the difference between the Expenses (% of total expenses) of Jordan in 2010 and the Expenses (% of total expenses) of Slovak Republic in 2011?
Your answer should be compact. -36.15. What is the average Expenses (% of total expenses) of Denmark per year?
Offer a terse response. 41.97. What is the average Expenses (% of total expenses) of Italy per year?
Offer a very short reply. 63.33. What is the average Expenses (% of total expenses) of Jordan per year?
Offer a terse response. 30.25. What is the average Expenses (% of total expenses) of Slovak Republic per year?
Give a very brief answer. 62.98. In the year 2004, what is the difference between the Expenses (% of total expenses) in Denmark and Expenses (% of total expenses) in Italy?
Your response must be concise. 5.37. In the year 2004, what is the difference between the Expenses (% of total expenses) of Denmark and Expenses (% of total expenses) of Jordan?
Your answer should be very brief. 49.67. In the year 2004, what is the difference between the Expenses (% of total expenses) in Denmark and Expenses (% of total expenses) in Slovak Republic?
Keep it short and to the point. 6.72. In the year 2004, what is the difference between the Expenses (% of total expenses) of Italy and Expenses (% of total expenses) of Jordan?
Offer a very short reply. 44.3. In the year 2004, what is the difference between the Expenses (% of total expenses) of Italy and Expenses (% of total expenses) of Slovak Republic?
Keep it short and to the point. 1.35. In the year 2004, what is the difference between the Expenses (% of total expenses) of Jordan and Expenses (% of total expenses) of Slovak Republic?
Provide a succinct answer. -42.95. In the year 2005, what is the difference between the Expenses (% of total expenses) in Denmark and Expenses (% of total expenses) in Italy?
Offer a terse response. 5.9. In the year 2005, what is the difference between the Expenses (% of total expenses) in Denmark and Expenses (% of total expenses) in Jordan?
Ensure brevity in your answer.  29.94. In the year 2005, what is the difference between the Expenses (% of total expenses) of Denmark and Expenses (% of total expenses) of Slovak Republic?
Provide a short and direct response. 7.19. In the year 2005, what is the difference between the Expenses (% of total expenses) of Italy and Expenses (% of total expenses) of Jordan?
Offer a very short reply. 24.04. In the year 2005, what is the difference between the Expenses (% of total expenses) in Italy and Expenses (% of total expenses) in Slovak Republic?
Give a very brief answer. 1.29. In the year 2005, what is the difference between the Expenses (% of total expenses) of Jordan and Expenses (% of total expenses) of Slovak Republic?
Provide a succinct answer. -22.75. In the year 2006, what is the difference between the Expenses (% of total expenses) of Denmark and Expenses (% of total expenses) of Italy?
Provide a short and direct response. 7.62. In the year 2006, what is the difference between the Expenses (% of total expenses) in Denmark and Expenses (% of total expenses) in Jordan?
Offer a terse response. 37.81. In the year 2006, what is the difference between the Expenses (% of total expenses) in Denmark and Expenses (% of total expenses) in Slovak Republic?
Provide a succinct answer. 8.88. In the year 2006, what is the difference between the Expenses (% of total expenses) in Italy and Expenses (% of total expenses) in Jordan?
Keep it short and to the point. 30.18. In the year 2006, what is the difference between the Expenses (% of total expenses) of Italy and Expenses (% of total expenses) of Slovak Republic?
Your answer should be very brief. 1.26. In the year 2006, what is the difference between the Expenses (% of total expenses) of Jordan and Expenses (% of total expenses) of Slovak Republic?
Keep it short and to the point. -28.93. In the year 2007, what is the difference between the Expenses (% of total expenses) of Denmark and Expenses (% of total expenses) of Italy?
Provide a succinct answer. 8.48. In the year 2007, what is the difference between the Expenses (% of total expenses) in Denmark and Expenses (% of total expenses) in Jordan?
Keep it short and to the point. 44.46. In the year 2007, what is the difference between the Expenses (% of total expenses) of Denmark and Expenses (% of total expenses) of Slovak Republic?
Ensure brevity in your answer.  5.96. In the year 2007, what is the difference between the Expenses (% of total expenses) of Italy and Expenses (% of total expenses) of Jordan?
Offer a terse response. 35.98. In the year 2007, what is the difference between the Expenses (% of total expenses) of Italy and Expenses (% of total expenses) of Slovak Republic?
Make the answer very short. -2.51. In the year 2007, what is the difference between the Expenses (% of total expenses) in Jordan and Expenses (% of total expenses) in Slovak Republic?
Make the answer very short. -38.49. In the year 2008, what is the difference between the Expenses (% of total expenses) of Denmark and Expenses (% of total expenses) of Italy?
Offer a terse response. -48.61. In the year 2008, what is the difference between the Expenses (% of total expenses) of Denmark and Expenses (% of total expenses) of Jordan?
Your answer should be compact. -18.28. In the year 2008, what is the difference between the Expenses (% of total expenses) in Denmark and Expenses (% of total expenses) in Slovak Republic?
Keep it short and to the point. -50.09. In the year 2008, what is the difference between the Expenses (% of total expenses) of Italy and Expenses (% of total expenses) of Jordan?
Provide a succinct answer. 30.33. In the year 2008, what is the difference between the Expenses (% of total expenses) of Italy and Expenses (% of total expenses) of Slovak Republic?
Ensure brevity in your answer.  -1.48. In the year 2008, what is the difference between the Expenses (% of total expenses) of Jordan and Expenses (% of total expenses) of Slovak Republic?
Offer a terse response. -31.81. In the year 2009, what is the difference between the Expenses (% of total expenses) of Denmark and Expenses (% of total expenses) of Italy?
Offer a terse response. -49.59. In the year 2009, what is the difference between the Expenses (% of total expenses) in Denmark and Expenses (% of total expenses) in Jordan?
Offer a very short reply. -14.45. In the year 2009, what is the difference between the Expenses (% of total expenses) of Denmark and Expenses (% of total expenses) of Slovak Republic?
Make the answer very short. -47.49. In the year 2009, what is the difference between the Expenses (% of total expenses) in Italy and Expenses (% of total expenses) in Jordan?
Your response must be concise. 35.14. In the year 2009, what is the difference between the Expenses (% of total expenses) of Italy and Expenses (% of total expenses) of Slovak Republic?
Your answer should be compact. 2.1. In the year 2009, what is the difference between the Expenses (% of total expenses) of Jordan and Expenses (% of total expenses) of Slovak Republic?
Your answer should be compact. -33.04. In the year 2010, what is the difference between the Expenses (% of total expenses) of Denmark and Expenses (% of total expenses) of Italy?
Ensure brevity in your answer.  -50.1. In the year 2010, what is the difference between the Expenses (% of total expenses) of Denmark and Expenses (% of total expenses) of Jordan?
Your response must be concise. -13.19. In the year 2010, what is the difference between the Expenses (% of total expenses) of Denmark and Expenses (% of total expenses) of Slovak Republic?
Provide a short and direct response. -49.64. In the year 2010, what is the difference between the Expenses (% of total expenses) in Italy and Expenses (% of total expenses) in Jordan?
Ensure brevity in your answer.  36.91. In the year 2010, what is the difference between the Expenses (% of total expenses) in Italy and Expenses (% of total expenses) in Slovak Republic?
Provide a short and direct response. 0.46. In the year 2010, what is the difference between the Expenses (% of total expenses) of Jordan and Expenses (% of total expenses) of Slovak Republic?
Offer a very short reply. -36.45. In the year 2011, what is the difference between the Expenses (% of total expenses) of Denmark and Expenses (% of total expenses) of Italy?
Your response must be concise. -49.94. In the year 2011, what is the difference between the Expenses (% of total expenses) of Denmark and Expenses (% of total expenses) of Jordan?
Offer a very short reply. -22.26. In the year 2011, what is the difference between the Expenses (% of total expenses) in Denmark and Expenses (% of total expenses) in Slovak Republic?
Provide a short and direct response. -49.67. In the year 2011, what is the difference between the Expenses (% of total expenses) in Italy and Expenses (% of total expenses) in Jordan?
Your answer should be very brief. 27.69. In the year 2011, what is the difference between the Expenses (% of total expenses) of Italy and Expenses (% of total expenses) of Slovak Republic?
Provide a succinct answer. 0.27. In the year 2011, what is the difference between the Expenses (% of total expenses) of Jordan and Expenses (% of total expenses) of Slovak Republic?
Keep it short and to the point. -27.42. What is the ratio of the Expenses (% of total expenses) in Jordan in 2004 to that in 2005?
Offer a very short reply. 0.47. What is the ratio of the Expenses (% of total expenses) of Denmark in 2004 to that in 2006?
Offer a terse response. 0.98. What is the ratio of the Expenses (% of total expenses) in Italy in 2004 to that in 2006?
Offer a terse response. 1.02. What is the ratio of the Expenses (% of total expenses) in Jordan in 2004 to that in 2006?
Your response must be concise. 0.58. What is the ratio of the Expenses (% of total expenses) of Slovak Republic in 2004 to that in 2006?
Your answer should be compact. 1.02. What is the ratio of the Expenses (% of total expenses) of Denmark in 2004 to that in 2007?
Provide a short and direct response. 0.95. What is the ratio of the Expenses (% of total expenses) in Italy in 2004 to that in 2007?
Give a very brief answer. 1. What is the ratio of the Expenses (% of total expenses) in Jordan in 2004 to that in 2007?
Your response must be concise. 0.68. What is the ratio of the Expenses (% of total expenses) in Slovak Republic in 2004 to that in 2007?
Your response must be concise. 0.94. What is the ratio of the Expenses (% of total expenses) of Denmark in 2004 to that in 2008?
Provide a succinct answer. 4.64. What is the ratio of the Expenses (% of total expenses) in Italy in 2004 to that in 2008?
Keep it short and to the point. 0.98. What is the ratio of the Expenses (% of total expenses) of Jordan in 2004 to that in 2008?
Give a very brief answer. 0.54. What is the ratio of the Expenses (% of total expenses) in Slovak Republic in 2004 to that in 2008?
Ensure brevity in your answer.  0.94. What is the ratio of the Expenses (% of total expenses) in Denmark in 2004 to that in 2009?
Provide a succinct answer. 4.39. What is the ratio of the Expenses (% of total expenses) of Jordan in 2004 to that in 2009?
Your answer should be compact. 0.6. What is the ratio of the Expenses (% of total expenses) of Slovak Republic in 2004 to that in 2009?
Give a very brief answer. 0.97. What is the ratio of the Expenses (% of total expenses) of Denmark in 2004 to that in 2010?
Ensure brevity in your answer.  4.36. What is the ratio of the Expenses (% of total expenses) in Italy in 2004 to that in 2010?
Give a very brief answer. 0.95. What is the ratio of the Expenses (% of total expenses) in Jordan in 2004 to that in 2010?
Ensure brevity in your answer.  0.62. What is the ratio of the Expenses (% of total expenses) in Slovak Republic in 2004 to that in 2010?
Make the answer very short. 0.93. What is the ratio of the Expenses (% of total expenses) in Denmark in 2004 to that in 2011?
Provide a short and direct response. 4.46. What is the ratio of the Expenses (% of total expenses) in Italy in 2004 to that in 2011?
Provide a short and direct response. 0.96. What is the ratio of the Expenses (% of total expenses) in Jordan in 2004 to that in 2011?
Offer a very short reply. 0.48. What is the ratio of the Expenses (% of total expenses) of Slovak Republic in 2004 to that in 2011?
Offer a very short reply. 0.94. What is the ratio of the Expenses (% of total expenses) of Italy in 2005 to that in 2006?
Provide a succinct answer. 1.02. What is the ratio of the Expenses (% of total expenses) in Jordan in 2005 to that in 2006?
Your answer should be compact. 1.24. What is the ratio of the Expenses (% of total expenses) in Denmark in 2005 to that in 2007?
Give a very brief answer. 0.96. What is the ratio of the Expenses (% of total expenses) of Jordan in 2005 to that in 2007?
Offer a very short reply. 1.45. What is the ratio of the Expenses (% of total expenses) in Slovak Republic in 2005 to that in 2007?
Ensure brevity in your answer.  0.94. What is the ratio of the Expenses (% of total expenses) of Denmark in 2005 to that in 2008?
Provide a short and direct response. 4.69. What is the ratio of the Expenses (% of total expenses) in Italy in 2005 to that in 2008?
Your answer should be compact. 0.99. What is the ratio of the Expenses (% of total expenses) of Jordan in 2005 to that in 2008?
Ensure brevity in your answer.  1.17. What is the ratio of the Expenses (% of total expenses) in Slovak Republic in 2005 to that in 2008?
Your answer should be very brief. 0.94. What is the ratio of the Expenses (% of total expenses) of Denmark in 2005 to that in 2009?
Give a very brief answer. 4.44. What is the ratio of the Expenses (% of total expenses) of Italy in 2005 to that in 2009?
Ensure brevity in your answer.  0.96. What is the ratio of the Expenses (% of total expenses) of Jordan in 2005 to that in 2009?
Offer a terse response. 1.28. What is the ratio of the Expenses (% of total expenses) in Slovak Republic in 2005 to that in 2009?
Provide a short and direct response. 0.97. What is the ratio of the Expenses (% of total expenses) of Denmark in 2005 to that in 2010?
Ensure brevity in your answer.  4.41. What is the ratio of the Expenses (% of total expenses) in Italy in 2005 to that in 2010?
Provide a short and direct response. 0.95. What is the ratio of the Expenses (% of total expenses) in Jordan in 2005 to that in 2010?
Keep it short and to the point. 1.34. What is the ratio of the Expenses (% of total expenses) in Slovak Republic in 2005 to that in 2010?
Provide a short and direct response. 0.94. What is the ratio of the Expenses (% of total expenses) of Denmark in 2005 to that in 2011?
Provide a succinct answer. 4.51. What is the ratio of the Expenses (% of total expenses) in Italy in 2005 to that in 2011?
Keep it short and to the point. 0.96. What is the ratio of the Expenses (% of total expenses) of Jordan in 2005 to that in 2011?
Ensure brevity in your answer.  1.02. What is the ratio of the Expenses (% of total expenses) in Slovak Republic in 2005 to that in 2011?
Make the answer very short. 0.94. What is the ratio of the Expenses (% of total expenses) of Denmark in 2006 to that in 2007?
Your response must be concise. 0.97. What is the ratio of the Expenses (% of total expenses) in Italy in 2006 to that in 2007?
Ensure brevity in your answer.  0.98. What is the ratio of the Expenses (% of total expenses) of Jordan in 2006 to that in 2007?
Make the answer very short. 1.17. What is the ratio of the Expenses (% of total expenses) in Slovak Republic in 2006 to that in 2007?
Ensure brevity in your answer.  0.92. What is the ratio of the Expenses (% of total expenses) of Denmark in 2006 to that in 2008?
Offer a terse response. 4.71. What is the ratio of the Expenses (% of total expenses) of Italy in 2006 to that in 2008?
Offer a very short reply. 0.97. What is the ratio of the Expenses (% of total expenses) of Jordan in 2006 to that in 2008?
Ensure brevity in your answer.  0.94. What is the ratio of the Expenses (% of total expenses) of Slovak Republic in 2006 to that in 2008?
Ensure brevity in your answer.  0.92. What is the ratio of the Expenses (% of total expenses) in Denmark in 2006 to that in 2009?
Ensure brevity in your answer.  4.46. What is the ratio of the Expenses (% of total expenses) in Italy in 2006 to that in 2009?
Your answer should be very brief. 0.94. What is the ratio of the Expenses (% of total expenses) of Jordan in 2006 to that in 2009?
Keep it short and to the point. 1.03. What is the ratio of the Expenses (% of total expenses) of Slovak Republic in 2006 to that in 2009?
Ensure brevity in your answer.  0.95. What is the ratio of the Expenses (% of total expenses) in Denmark in 2006 to that in 2010?
Provide a succinct answer. 4.43. What is the ratio of the Expenses (% of total expenses) in Italy in 2006 to that in 2010?
Provide a short and direct response. 0.93. What is the ratio of the Expenses (% of total expenses) of Jordan in 2006 to that in 2010?
Your response must be concise. 1.07. What is the ratio of the Expenses (% of total expenses) in Slovak Republic in 2006 to that in 2010?
Give a very brief answer. 0.92. What is the ratio of the Expenses (% of total expenses) in Denmark in 2006 to that in 2011?
Offer a terse response. 4.53. What is the ratio of the Expenses (% of total expenses) of Italy in 2006 to that in 2011?
Offer a very short reply. 0.94. What is the ratio of the Expenses (% of total expenses) in Jordan in 2006 to that in 2011?
Make the answer very short. 0.82. What is the ratio of the Expenses (% of total expenses) of Slovak Republic in 2006 to that in 2011?
Ensure brevity in your answer.  0.92. What is the ratio of the Expenses (% of total expenses) of Denmark in 2007 to that in 2008?
Provide a succinct answer. 4.86. What is the ratio of the Expenses (% of total expenses) of Italy in 2007 to that in 2008?
Offer a terse response. 0.99. What is the ratio of the Expenses (% of total expenses) of Jordan in 2007 to that in 2008?
Your answer should be compact. 0.8. What is the ratio of the Expenses (% of total expenses) of Denmark in 2007 to that in 2009?
Offer a very short reply. 4.61. What is the ratio of the Expenses (% of total expenses) of Italy in 2007 to that in 2009?
Your answer should be very brief. 0.96. What is the ratio of the Expenses (% of total expenses) of Jordan in 2007 to that in 2009?
Give a very brief answer. 0.88. What is the ratio of the Expenses (% of total expenses) in Slovak Republic in 2007 to that in 2009?
Make the answer very short. 1.03. What is the ratio of the Expenses (% of total expenses) of Denmark in 2007 to that in 2010?
Provide a succinct answer. 4.57. What is the ratio of the Expenses (% of total expenses) in Italy in 2007 to that in 2010?
Offer a terse response. 0.95. What is the ratio of the Expenses (% of total expenses) in Jordan in 2007 to that in 2010?
Keep it short and to the point. 0.92. What is the ratio of the Expenses (% of total expenses) in Slovak Republic in 2007 to that in 2010?
Offer a terse response. 1. What is the ratio of the Expenses (% of total expenses) of Denmark in 2007 to that in 2011?
Make the answer very short. 4.67. What is the ratio of the Expenses (% of total expenses) in Italy in 2007 to that in 2011?
Make the answer very short. 0.96. What is the ratio of the Expenses (% of total expenses) of Jordan in 2007 to that in 2011?
Make the answer very short. 0.7. What is the ratio of the Expenses (% of total expenses) in Denmark in 2008 to that in 2009?
Your answer should be very brief. 0.95. What is the ratio of the Expenses (% of total expenses) in Italy in 2008 to that in 2009?
Your response must be concise. 0.97. What is the ratio of the Expenses (% of total expenses) in Jordan in 2008 to that in 2009?
Your response must be concise. 1.1. What is the ratio of the Expenses (% of total expenses) in Slovak Republic in 2008 to that in 2009?
Keep it short and to the point. 1.03. What is the ratio of the Expenses (% of total expenses) in Denmark in 2008 to that in 2010?
Provide a short and direct response. 0.94. What is the ratio of the Expenses (% of total expenses) in Italy in 2008 to that in 2010?
Offer a very short reply. 0.96. What is the ratio of the Expenses (% of total expenses) of Jordan in 2008 to that in 2010?
Ensure brevity in your answer.  1.15. What is the ratio of the Expenses (% of total expenses) in Slovak Republic in 2008 to that in 2010?
Your response must be concise. 0.99. What is the ratio of the Expenses (% of total expenses) of Denmark in 2008 to that in 2011?
Your answer should be very brief. 0.96. What is the ratio of the Expenses (% of total expenses) of Italy in 2008 to that in 2011?
Offer a terse response. 0.97. What is the ratio of the Expenses (% of total expenses) of Jordan in 2008 to that in 2011?
Make the answer very short. 0.88. What is the ratio of the Expenses (% of total expenses) of Jordan in 2009 to that in 2010?
Make the answer very short. 1.04. What is the ratio of the Expenses (% of total expenses) of Slovak Republic in 2009 to that in 2010?
Your answer should be compact. 0.97. What is the ratio of the Expenses (% of total expenses) of Denmark in 2009 to that in 2011?
Make the answer very short. 1.01. What is the ratio of the Expenses (% of total expenses) in Jordan in 2009 to that in 2011?
Provide a short and direct response. 0.8. What is the ratio of the Expenses (% of total expenses) of Slovak Republic in 2009 to that in 2011?
Your answer should be compact. 0.97. What is the ratio of the Expenses (% of total expenses) in Italy in 2010 to that in 2011?
Offer a terse response. 1.01. What is the ratio of the Expenses (% of total expenses) in Jordan in 2010 to that in 2011?
Keep it short and to the point. 0.77. What is the ratio of the Expenses (% of total expenses) of Slovak Republic in 2010 to that in 2011?
Offer a very short reply. 1. What is the difference between the highest and the second highest Expenses (% of total expenses) of Denmark?
Your answer should be very brief. 2.17. What is the difference between the highest and the second highest Expenses (% of total expenses) of Italy?
Give a very brief answer. 0.49. What is the difference between the highest and the second highest Expenses (% of total expenses) in Jordan?
Keep it short and to the point. 0.9. What is the difference between the highest and the second highest Expenses (% of total expenses) in Slovak Republic?
Make the answer very short. 0.3. What is the difference between the highest and the lowest Expenses (% of total expenses) in Denmark?
Provide a succinct answer. 56.23. What is the difference between the highest and the lowest Expenses (% of total expenses) in Italy?
Give a very brief answer. 4.59. What is the difference between the highest and the lowest Expenses (% of total expenses) in Jordan?
Provide a short and direct response. 20.43. What is the difference between the highest and the lowest Expenses (% of total expenses) in Slovak Republic?
Provide a succinct answer. 5.38. 